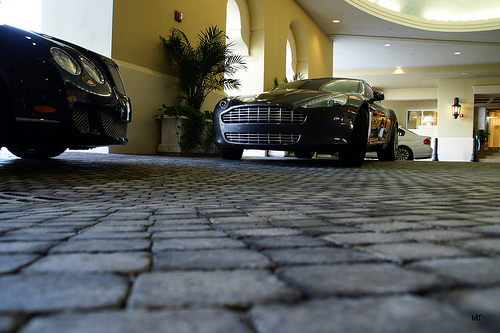<image>
Is the plant in front of the car? No. The plant is not in front of the car. The spatial positioning shows a different relationship between these objects. 